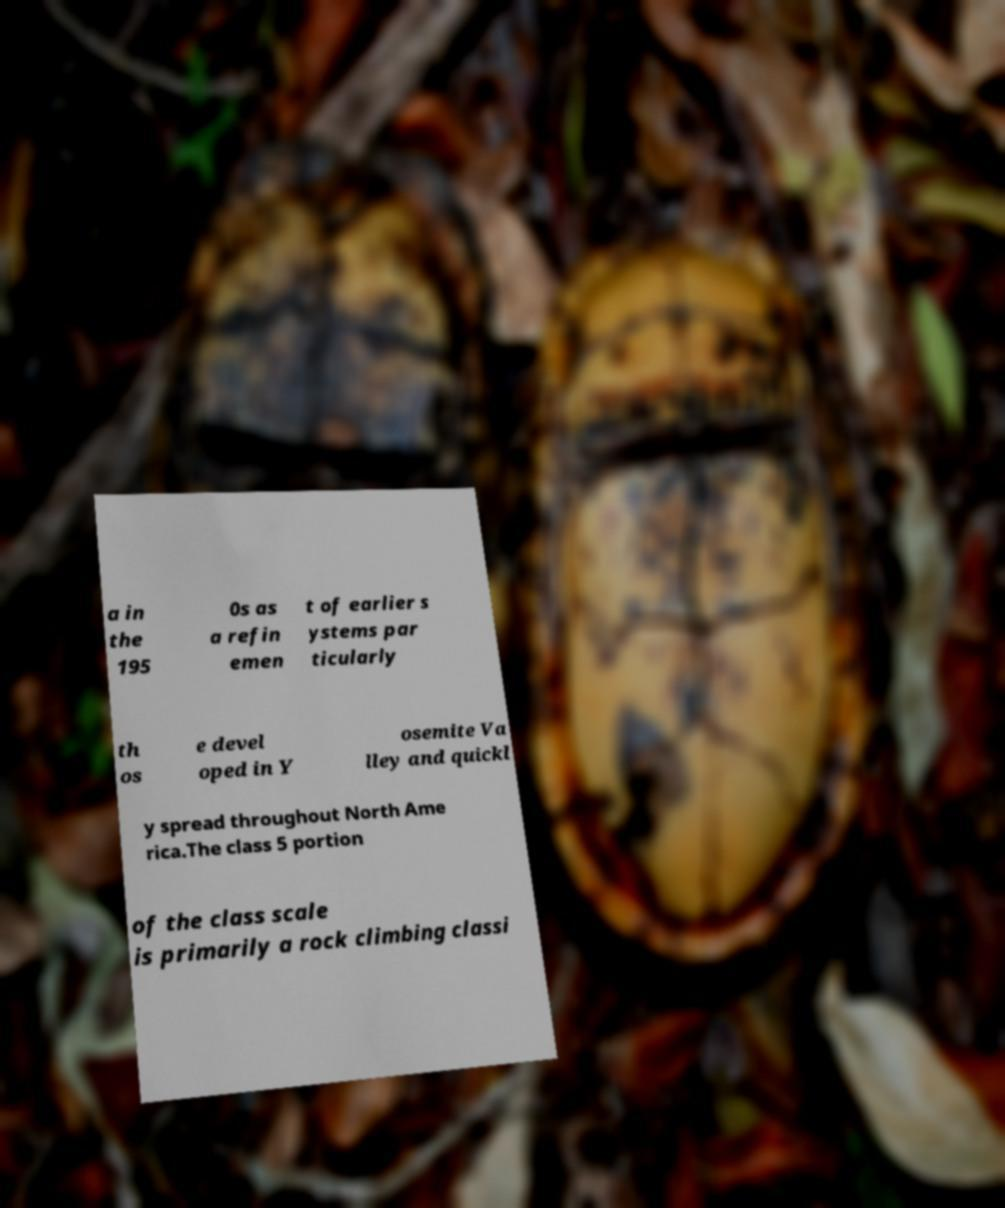I need the written content from this picture converted into text. Can you do that? a in the 195 0s as a refin emen t of earlier s ystems par ticularly th os e devel oped in Y osemite Va lley and quickl y spread throughout North Ame rica.The class 5 portion of the class scale is primarily a rock climbing classi 